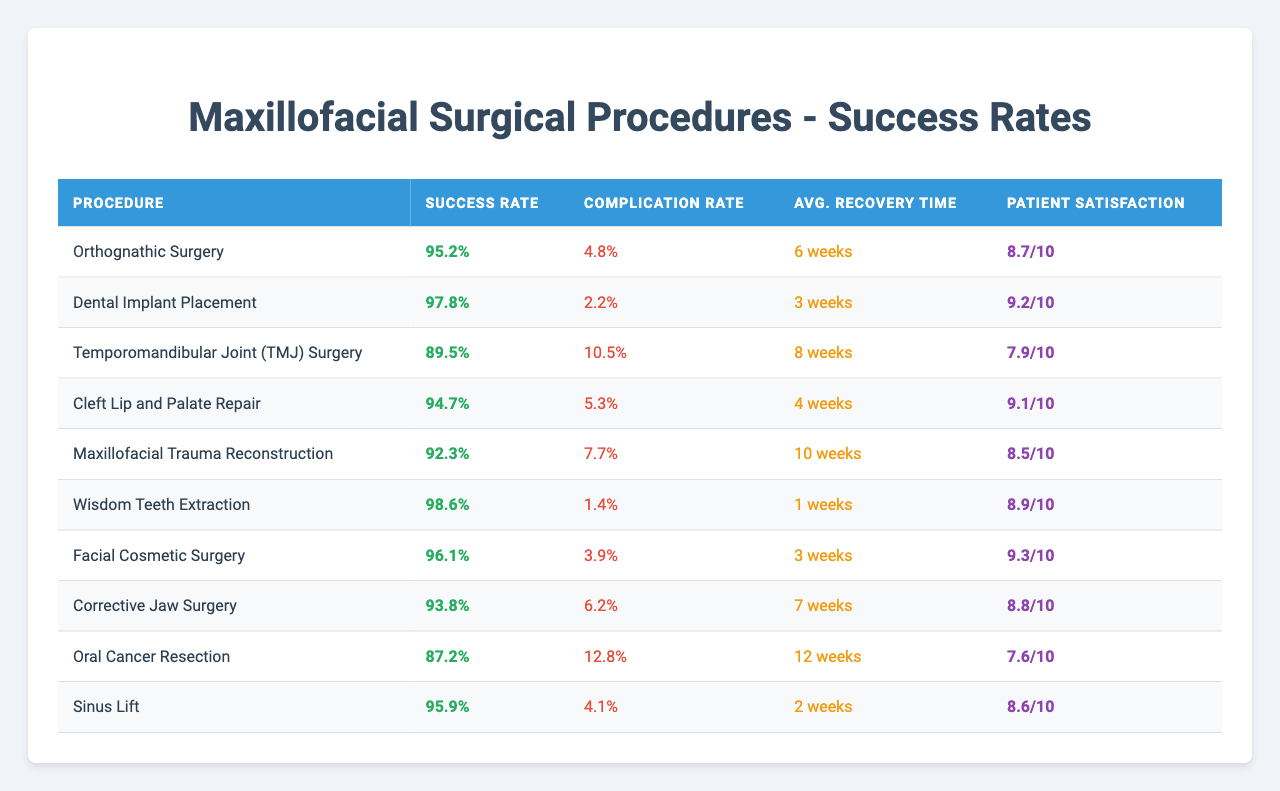What's the success rate of Dental Implant Placement? The table lists the success rate for each procedure, and for Dental Implant Placement, the success rate is shown as 97.8%.
Answer: 97.8% What is the average recovery time for Temporomandibular Joint (TMJ) Surgery? According to the table, the average recovery time for TMJ Surgery is stated as 8 weeks.
Answer: 8 weeks Which procedure has the highest patient satisfaction score? The patient satisfaction scores for each procedure are detailed in the table, and Dental Implant Placement has the highest score at 9.2.
Answer: Dental Implant Placement Is the complication rate for Wisdom Teeth Extraction less than 2%? The table indicates that the complication rate for Wisdom Teeth Extraction is 1.4%, which is less than 2%.
Answer: Yes What is the difference in success rates between Orthognathic Surgery and Corrective Jaw Surgery? From the table, Orthognathic Surgery has a success rate of 95.2% and Corrective Jaw Surgery has a success rate of 93.8%. The difference is 95.2 - 93.8 = 1.4%.
Answer: 1.4% Did Oral Cancer Resection receive a patient satisfaction score higher than 8? The patient satisfaction score for Oral Cancer Resection is 7.6, which is not higher than 8.
Answer: No If we consider the average recovery time for all procedures, how long does it take? The average recovery times for all procedures need to be summed up first. Adding the recovery times yields: 6 + 3 + 8 + 4 + 10 + 1 + 3 + 7 + 12 + 2 = 56 weeks. There are 10 procedures, so the average recovery time is 56 / 10 = 5.6 weeks.
Answer: 5.6 weeks What percentage of procedures has a success rate above 95%? Looking through the table, the procedures with success rates above 95% are Dental Implant Placement (97.8%), Wisdom Teeth Extraction (98.6%), and Facial Cosmetic Surgery (96.1%). That makes 3 out of 10 procedures. Therefore, the percentage is (3/10) * 100 = 30%.
Answer: 30% Which procedure has the lowest success rate, and what is that rate? By reviewing the success rates in the table, Oral Cancer Resection has the lowest success rate at 87.2%.
Answer: Oral Cancer Resection, 87.2% What is the average complication rate of the listed procedures? The complication rates from the table are 4.8, 2.2, 10.5, 5.3, 7.7, 1.4, 3.9, 6.2, 12.8, and 4.1. Adding these rates gives 54.9%, and dividing by the number of procedures (10) gives an average complication rate of 5.49%.
Answer: 5.49% 